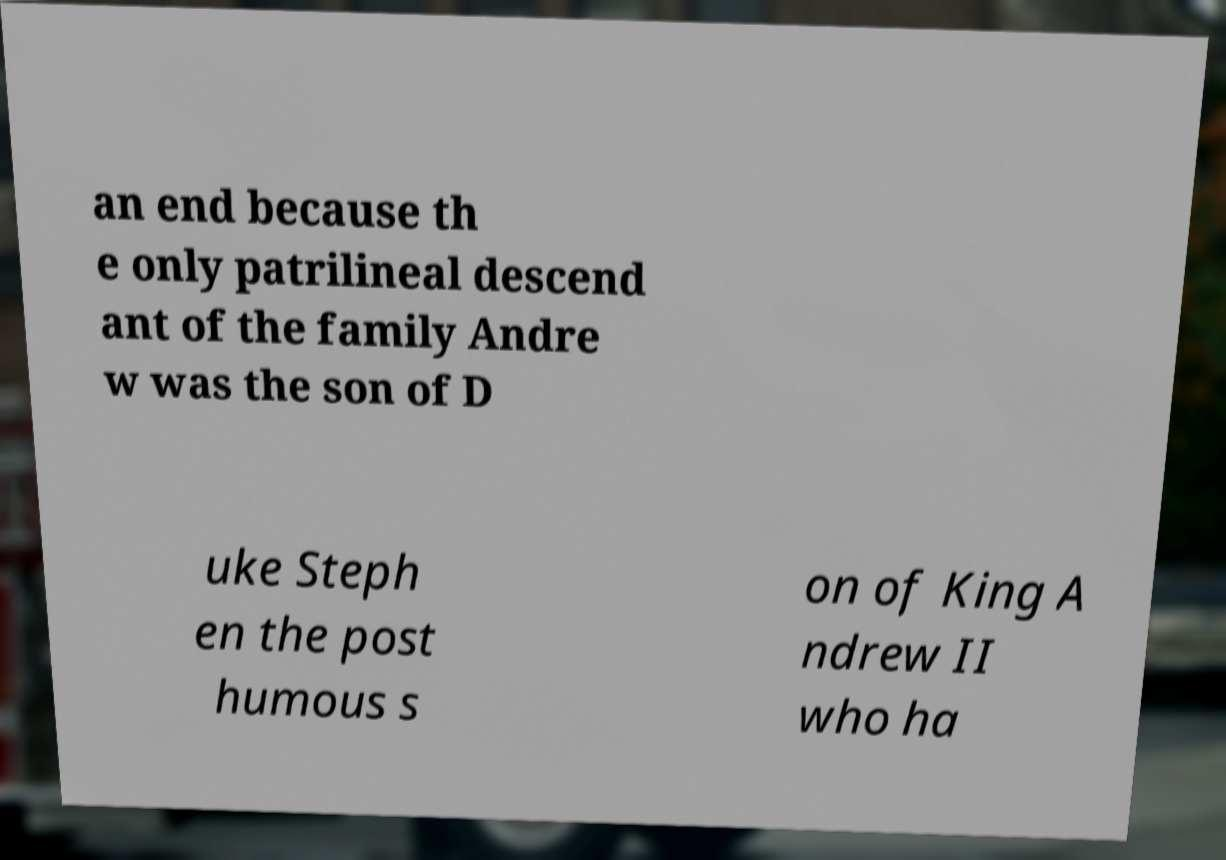Can you read and provide the text displayed in the image?This photo seems to have some interesting text. Can you extract and type it out for me? an end because th e only patrilineal descend ant of the family Andre w was the son of D uke Steph en the post humous s on of King A ndrew II who ha 